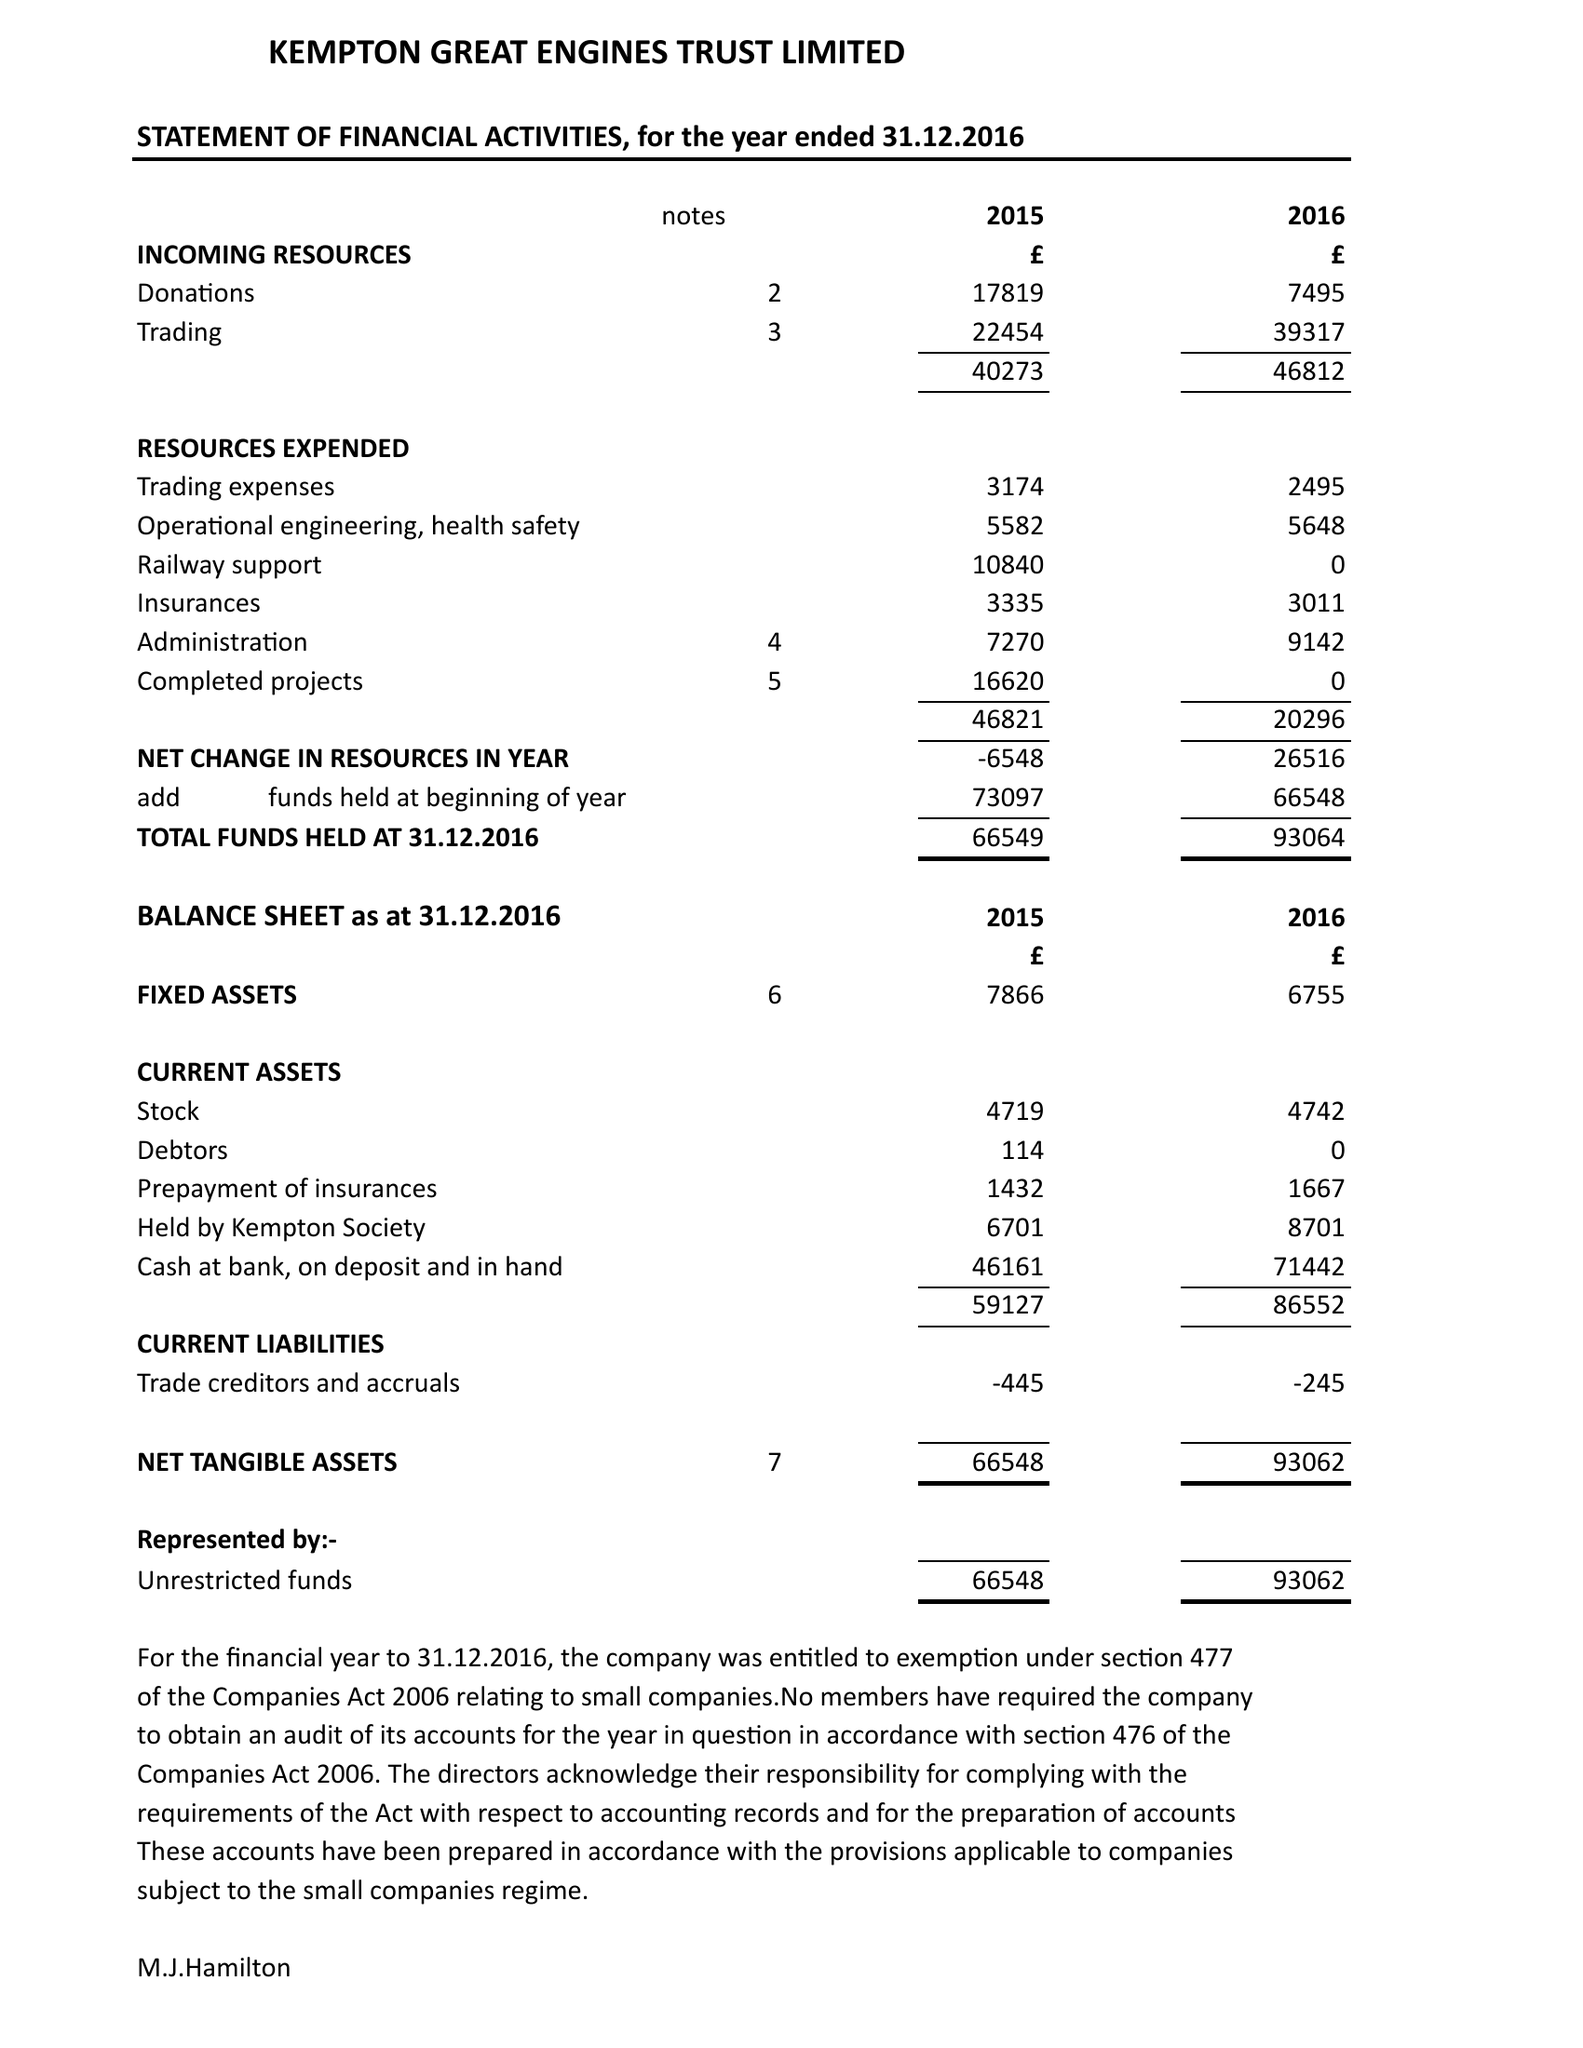What is the value for the income_annually_in_british_pounds?
Answer the question using a single word or phrase. 46812.00 